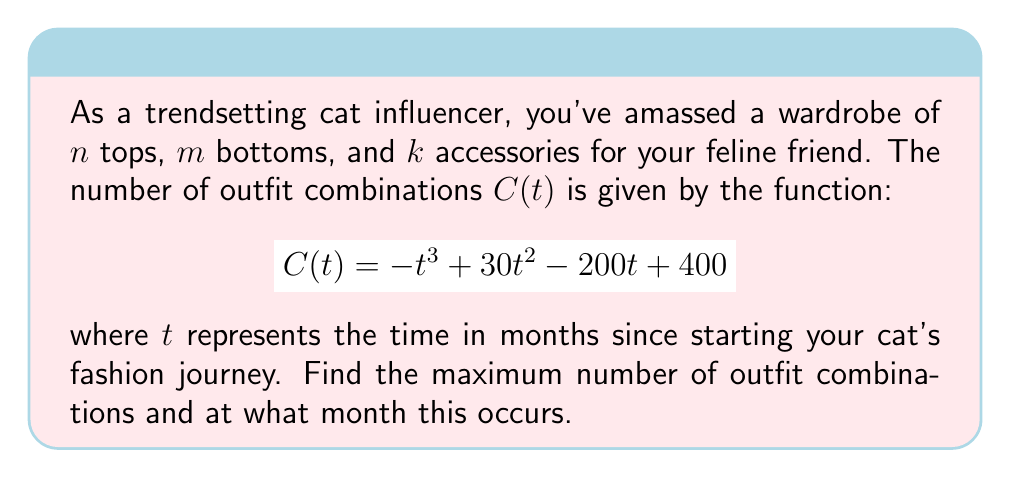Teach me how to tackle this problem. To find the maximum number of outfit combinations, we need to find the global maximum of the function $C(t)$. This can be done by following these steps:

1) First, we need to find the critical points by taking the derivative of $C(t)$ and setting it equal to zero:

   $$C'(t) = -3t^2 + 60t - 200$$
   $$-3t^2 + 60t - 200 = 0$$

2) This is a quadratic equation. We can solve it using the quadratic formula:
   
   $$t = \frac{-b \pm \sqrt{b^2 - 4ac}}{2a}$$
   
   where $a = -3$, $b = 60$, and $c = -200$

3) Plugging in these values:

   $$t = \frac{-60 \pm \sqrt{60^2 - 4(-3)(-200)}}{2(-3)}$$
   $$t = \frac{-60 \pm \sqrt{3600 - 2400}}{-6}$$
   $$t = \frac{-60 \pm \sqrt{1200}}{-6}$$
   $$t = \frac{-60 \pm 20\sqrt{3}}{-6}$$

4) This gives us two critical points:

   $$t_1 = \frac{-60 + 20\sqrt{3}}{-6} = 10 - \frac{10\sqrt{3}}{3}$$
   $$t_2 = \frac{-60 - 20\sqrt{3}}{-6} = 10 + \frac{10\sqrt{3}}{3}$$

5) To determine which of these gives the maximum, we can use the second derivative test:

   $$C''(t) = -6t + 60$$

6) Evaluating $C''(t)$ at $t_2$:

   $$C''(10 + \frac{10\sqrt{3}}{3}) = -6(10 + \frac{10\sqrt{3}}{3}) + 60 = -20\sqrt{3} < 0$$

   Since this is negative, $t_2$ gives us the maximum.

7) The maximum occurs at $t = 10 + \frac{10\sqrt{3}}{3}$ months, which is approximately 15.77 months.

8) To find the maximum number of combinations, we plug this value back into our original function:

   $$C(10 + \frac{10\sqrt{3}}{3}) = -(10 + \frac{10\sqrt{3}}{3})^3 + 30(10 + \frac{10\sqrt{3}}{3})^2 - 200(10 + \frac{10\sqrt{3}}{3}) + 400$$

9) Simplifying this expression (which involves some complex algebra) gives us the maximum number of combinations.
Answer: Maximum combinations: $\frac{1000}{3}(10 + 3\sqrt{3})$ at $10 + \frac{10\sqrt{3}}{3}$ months 